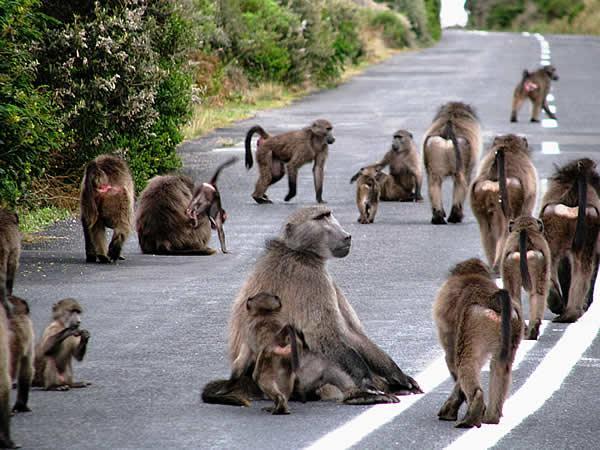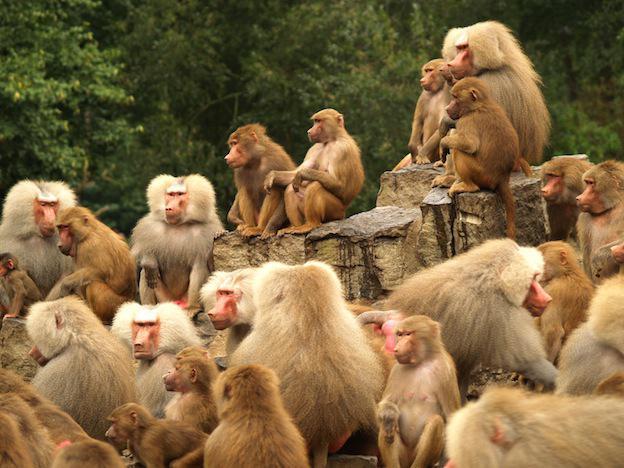The first image is the image on the left, the second image is the image on the right. Given the left and right images, does the statement "Baboons are mostly walking in one direction, in one image." hold true? Answer yes or no. Yes. The first image is the image on the left, the second image is the image on the right. Examine the images to the left and right. Is the description "There are no more than half a dozen primates in the image on the left." accurate? Answer yes or no. No. 